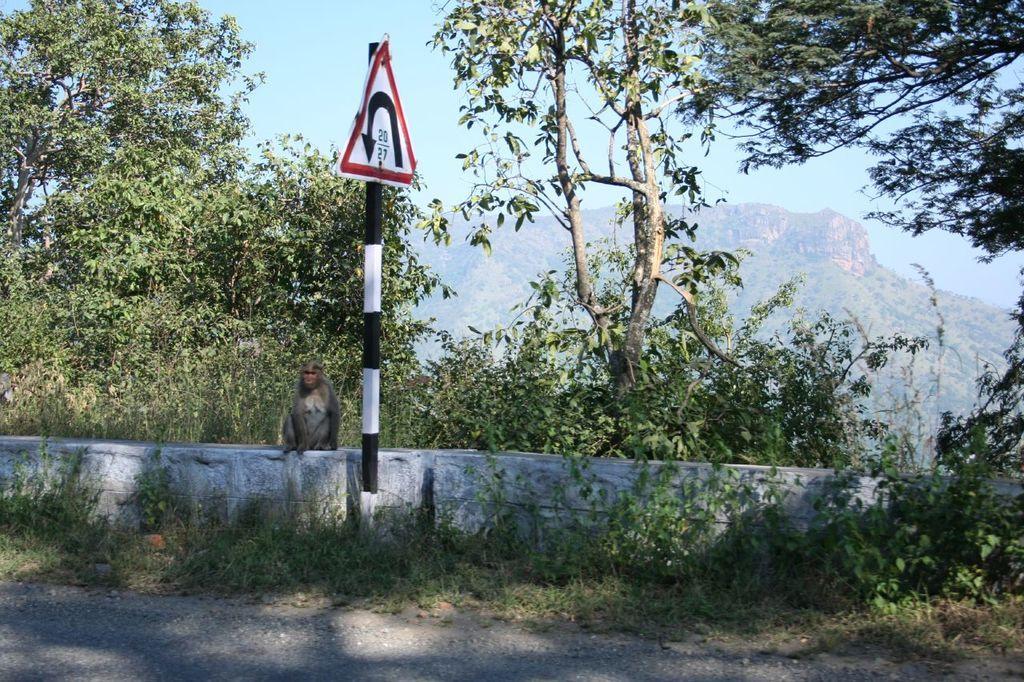In one or two sentences, can you explain what this image depicts? In front of the image there is a sign board, behind the sign board there is a monkey sitting on the concrete fence, behind the monkey there are trees, in the background of the image there are mountains. 